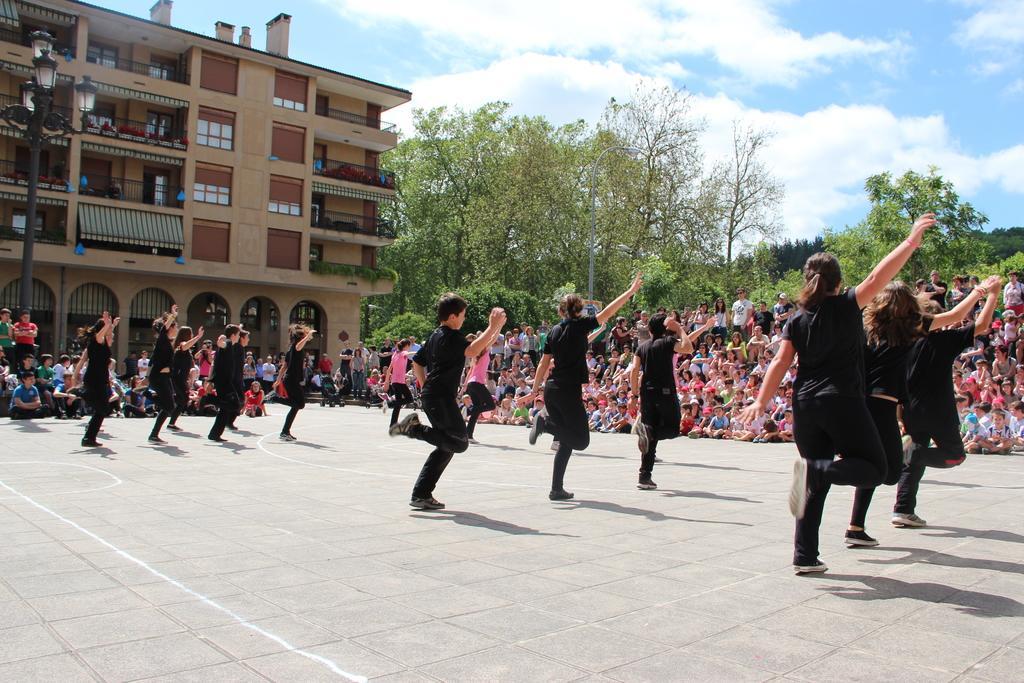Can you describe this image briefly? In this image there are group of people dancing, and in the background there are group of people , trees, building, lights to the pole, sky. 